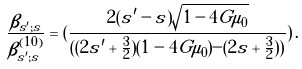<formula> <loc_0><loc_0><loc_500><loc_500>\frac { \beta _ { s ^ { \prime } ; s } } { \beta ^ { ( 1 0 ) } _ { s ^ { \prime } ; s } } = ( \frac { 2 ( s ^ { \prime } - s ) \sqrt { 1 - 4 G \mu _ { 0 } } } { ( ( 2 s ^ { \prime } + \frac { 3 } { 2 } ) ( 1 - 4 G \mu _ { 0 } ) - ( 2 s + \frac { 3 } { 2 } ) ) } ) \, .</formula> 